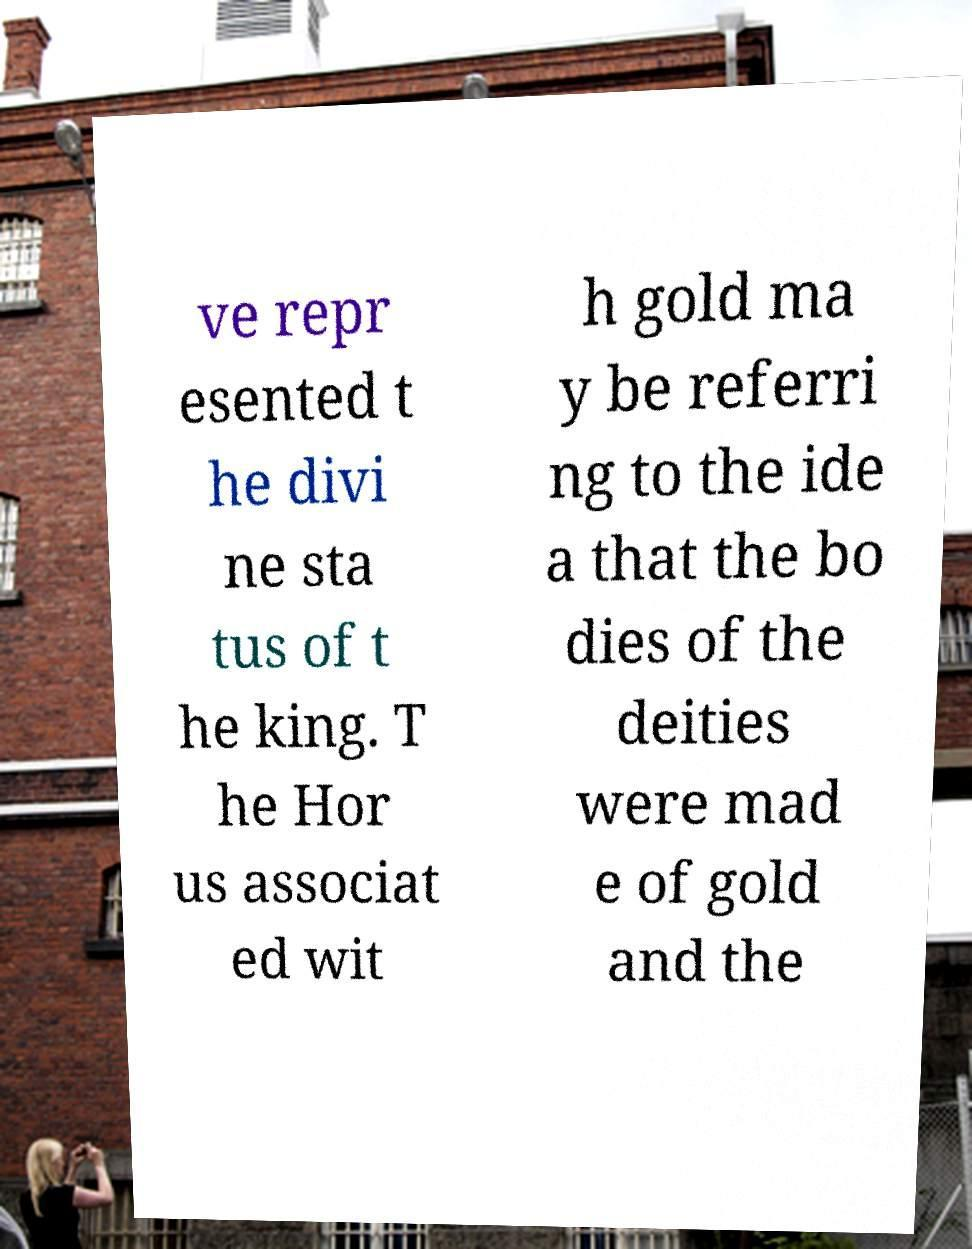Please identify and transcribe the text found in this image. ve repr esented t he divi ne sta tus of t he king. T he Hor us associat ed wit h gold ma y be referri ng to the ide a that the bo dies of the deities were mad e of gold and the 